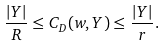Convert formula to latex. <formula><loc_0><loc_0><loc_500><loc_500>\frac { | Y | } { R } \leq C _ { D } ( w , Y ) \leq \frac { | Y | } { r } .</formula> 